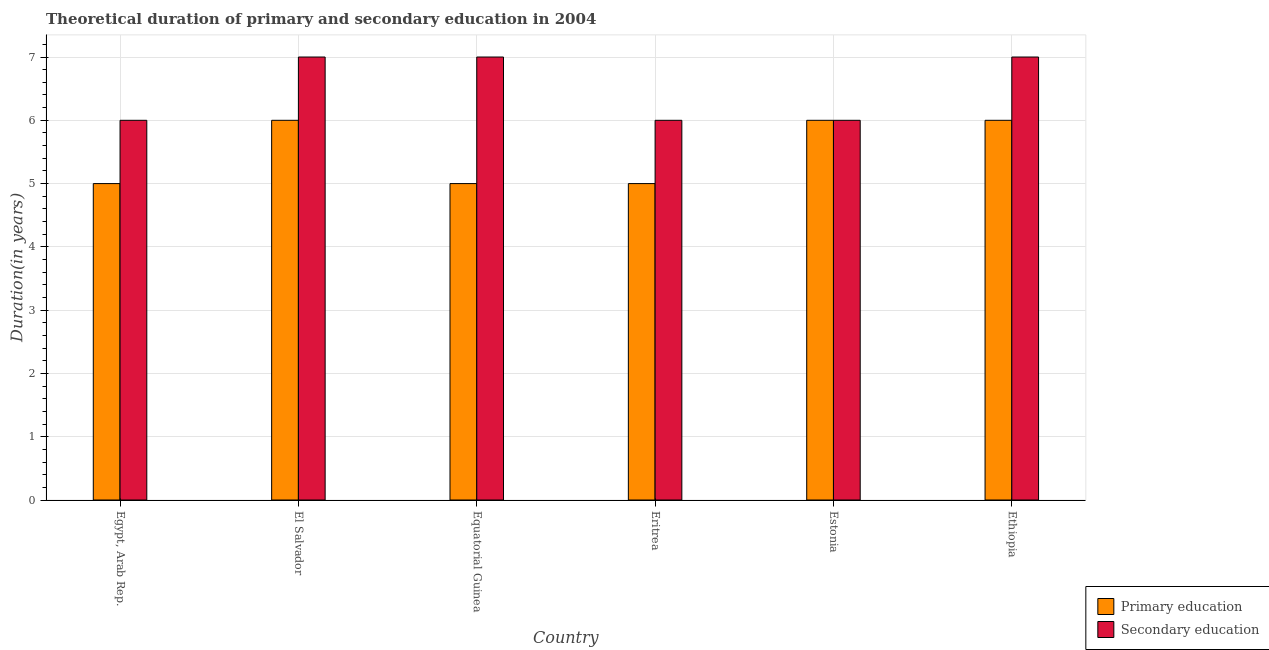How many groups of bars are there?
Give a very brief answer. 6. How many bars are there on the 2nd tick from the right?
Keep it short and to the point. 2. What is the label of the 5th group of bars from the left?
Provide a short and direct response. Estonia. In how many cases, is the number of bars for a given country not equal to the number of legend labels?
Offer a very short reply. 0. Across all countries, what is the maximum duration of secondary education?
Provide a short and direct response. 7. In which country was the duration of secondary education maximum?
Your answer should be compact. El Salvador. In which country was the duration of primary education minimum?
Ensure brevity in your answer.  Egypt, Arab Rep. What is the total duration of primary education in the graph?
Offer a very short reply. 33. What is the difference between the duration of secondary education in Egypt, Arab Rep. and that in Ethiopia?
Your response must be concise. -1. What is the difference between the duration of primary education in Equatorial Guinea and the duration of secondary education in El Salvador?
Your answer should be very brief. -2. What is the difference between the duration of secondary education and duration of primary education in Eritrea?
Keep it short and to the point. 1. Is the duration of primary education in Egypt, Arab Rep. less than that in El Salvador?
Provide a succinct answer. Yes. Is the difference between the duration of secondary education in El Salvador and Equatorial Guinea greater than the difference between the duration of primary education in El Salvador and Equatorial Guinea?
Offer a terse response. No. What is the difference between the highest and the lowest duration of primary education?
Make the answer very short. 1. Is the sum of the duration of primary education in El Salvador and Ethiopia greater than the maximum duration of secondary education across all countries?
Ensure brevity in your answer.  Yes. What does the 1st bar from the left in Equatorial Guinea represents?
Keep it short and to the point. Primary education. Are all the bars in the graph horizontal?
Ensure brevity in your answer.  No. Are the values on the major ticks of Y-axis written in scientific E-notation?
Your response must be concise. No. Where does the legend appear in the graph?
Make the answer very short. Bottom right. What is the title of the graph?
Ensure brevity in your answer.  Theoretical duration of primary and secondary education in 2004. Does "Malaria" appear as one of the legend labels in the graph?
Make the answer very short. No. What is the label or title of the X-axis?
Make the answer very short. Country. What is the label or title of the Y-axis?
Keep it short and to the point. Duration(in years). What is the Duration(in years) of Secondary education in Egypt, Arab Rep.?
Give a very brief answer. 6. What is the Duration(in years) in Primary education in El Salvador?
Offer a terse response. 6. What is the Duration(in years) in Primary education in Eritrea?
Give a very brief answer. 5. What is the Duration(in years) in Primary education in Estonia?
Ensure brevity in your answer.  6. What is the Duration(in years) in Secondary education in Estonia?
Ensure brevity in your answer.  6. Across all countries, what is the maximum Duration(in years) of Secondary education?
Provide a short and direct response. 7. Across all countries, what is the minimum Duration(in years) of Primary education?
Offer a very short reply. 5. What is the total Duration(in years) in Secondary education in the graph?
Keep it short and to the point. 39. What is the difference between the Duration(in years) of Secondary education in Egypt, Arab Rep. and that in El Salvador?
Your answer should be compact. -1. What is the difference between the Duration(in years) in Secondary education in Egypt, Arab Rep. and that in Estonia?
Keep it short and to the point. 0. What is the difference between the Duration(in years) in Primary education in Egypt, Arab Rep. and that in Ethiopia?
Give a very brief answer. -1. What is the difference between the Duration(in years) in Secondary education in Egypt, Arab Rep. and that in Ethiopia?
Your response must be concise. -1. What is the difference between the Duration(in years) in Primary education in El Salvador and that in Eritrea?
Provide a short and direct response. 1. What is the difference between the Duration(in years) in Secondary education in El Salvador and that in Eritrea?
Offer a very short reply. 1. What is the difference between the Duration(in years) in Primary education in El Salvador and that in Estonia?
Ensure brevity in your answer.  0. What is the difference between the Duration(in years) in Primary education in El Salvador and that in Ethiopia?
Give a very brief answer. 0. What is the difference between the Duration(in years) in Secondary education in El Salvador and that in Ethiopia?
Make the answer very short. 0. What is the difference between the Duration(in years) in Secondary education in Equatorial Guinea and that in Eritrea?
Give a very brief answer. 1. What is the difference between the Duration(in years) of Primary education in Eritrea and that in Ethiopia?
Your answer should be compact. -1. What is the difference between the Duration(in years) in Secondary education in Estonia and that in Ethiopia?
Your answer should be very brief. -1. What is the difference between the Duration(in years) of Primary education in Egypt, Arab Rep. and the Duration(in years) of Secondary education in Estonia?
Offer a terse response. -1. What is the difference between the Duration(in years) in Primary education in El Salvador and the Duration(in years) in Secondary education in Equatorial Guinea?
Your response must be concise. -1. What is the difference between the Duration(in years) of Primary education in El Salvador and the Duration(in years) of Secondary education in Estonia?
Offer a terse response. 0. What is the difference between the Duration(in years) of Primary education in El Salvador and the Duration(in years) of Secondary education in Ethiopia?
Make the answer very short. -1. What is the difference between the Duration(in years) of Primary education in Equatorial Guinea and the Duration(in years) of Secondary education in Estonia?
Your response must be concise. -1. What is the difference between the Duration(in years) in Primary education in Eritrea and the Duration(in years) in Secondary education in Estonia?
Keep it short and to the point. -1. What is the average Duration(in years) in Primary education per country?
Offer a terse response. 5.5. What is the difference between the Duration(in years) of Primary education and Duration(in years) of Secondary education in Egypt, Arab Rep.?
Ensure brevity in your answer.  -1. What is the difference between the Duration(in years) of Primary education and Duration(in years) of Secondary education in El Salvador?
Your response must be concise. -1. What is the difference between the Duration(in years) in Primary education and Duration(in years) in Secondary education in Equatorial Guinea?
Your answer should be compact. -2. What is the difference between the Duration(in years) of Primary education and Duration(in years) of Secondary education in Estonia?
Keep it short and to the point. 0. What is the difference between the Duration(in years) of Primary education and Duration(in years) of Secondary education in Ethiopia?
Your answer should be very brief. -1. What is the ratio of the Duration(in years) in Primary education in Egypt, Arab Rep. to that in El Salvador?
Make the answer very short. 0.83. What is the ratio of the Duration(in years) of Primary education in Egypt, Arab Rep. to that in Equatorial Guinea?
Ensure brevity in your answer.  1. What is the ratio of the Duration(in years) in Primary education in Egypt, Arab Rep. to that in Estonia?
Offer a very short reply. 0.83. What is the ratio of the Duration(in years) in Secondary education in Egypt, Arab Rep. to that in Estonia?
Provide a succinct answer. 1. What is the ratio of the Duration(in years) of Primary education in Egypt, Arab Rep. to that in Ethiopia?
Offer a terse response. 0.83. What is the ratio of the Duration(in years) of Secondary education in Egypt, Arab Rep. to that in Ethiopia?
Your answer should be compact. 0.86. What is the ratio of the Duration(in years) in Primary education in El Salvador to that in Equatorial Guinea?
Make the answer very short. 1.2. What is the ratio of the Duration(in years) in Secondary education in El Salvador to that in Equatorial Guinea?
Give a very brief answer. 1. What is the ratio of the Duration(in years) of Primary education in El Salvador to that in Ethiopia?
Give a very brief answer. 1. What is the ratio of the Duration(in years) of Primary education in Equatorial Guinea to that in Eritrea?
Your answer should be compact. 1. What is the ratio of the Duration(in years) in Primary education in Equatorial Guinea to that in Estonia?
Offer a very short reply. 0.83. What is the ratio of the Duration(in years) in Secondary education in Equatorial Guinea to that in Ethiopia?
Your answer should be compact. 1. What is the ratio of the Duration(in years) in Primary education in Eritrea to that in Estonia?
Your answer should be compact. 0.83. What is the ratio of the Duration(in years) of Secondary education in Eritrea to that in Ethiopia?
Give a very brief answer. 0.86. What is the ratio of the Duration(in years) of Secondary education in Estonia to that in Ethiopia?
Provide a succinct answer. 0.86. What is the difference between the highest and the second highest Duration(in years) of Secondary education?
Ensure brevity in your answer.  0. 